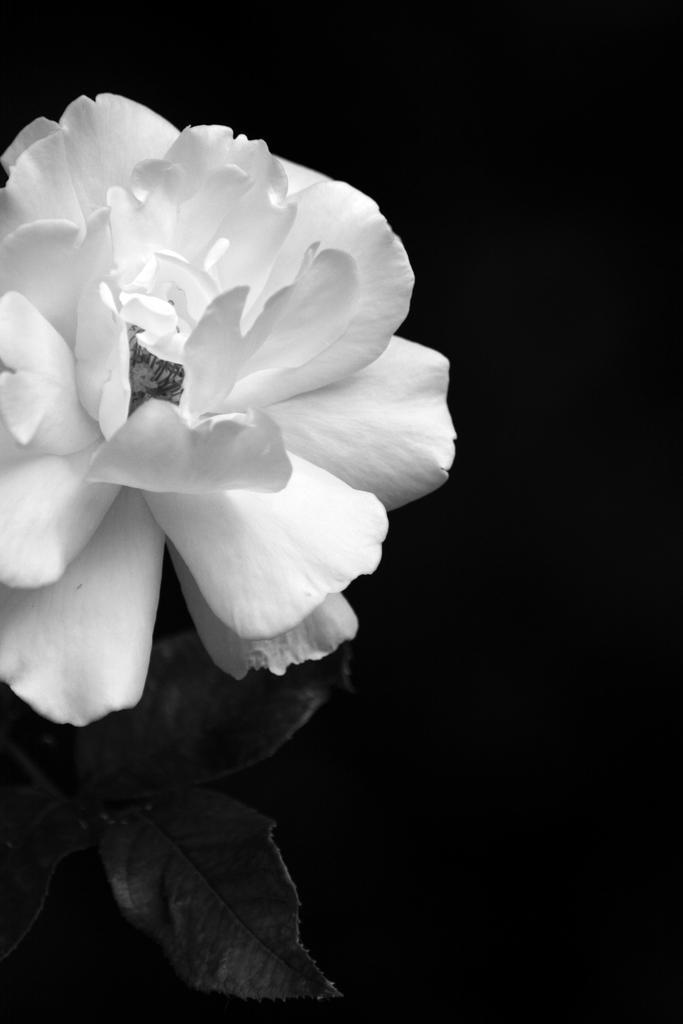Describe this image in one or two sentences. It is a flower in white color, this is black and white image. 